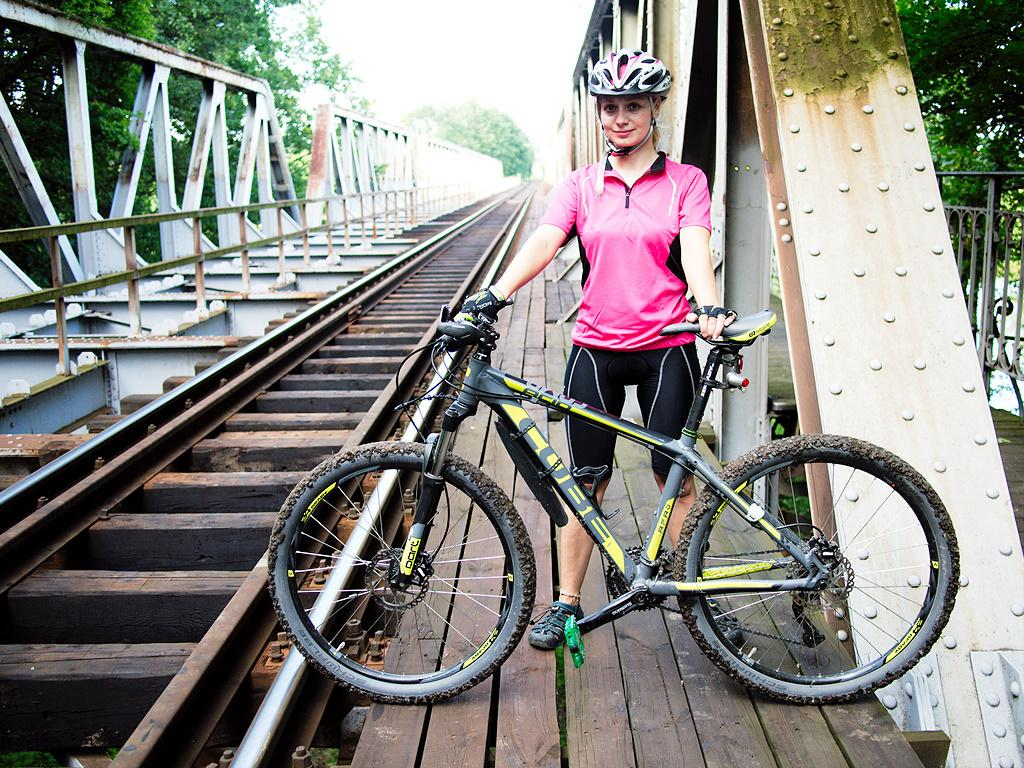Who is the main subject in the image? There is a woman in the image. What is the woman doing in the image? The woman is standing and holding a bicycle. What safety gear is the woman wearing in the image? The woman is wearing a helmet in the image. What can be seen in the background of the image? There are trees visible in the background of the image. What caption would best describe the woman's emotions in the image? There is no caption provided with the image, so it is not possible to determine the woman's emotions based on the image alone. What type of camera was used to capture the image? The type of camera used to capture the image is not mentioned in the provided facts, so it cannot be determined from the image. 